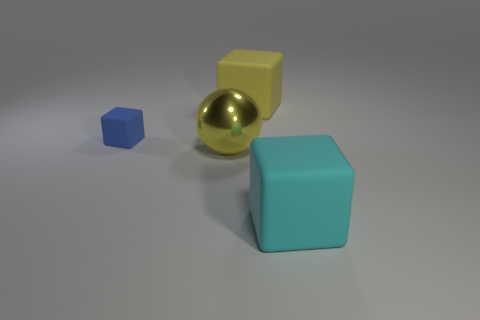Is there any other thing that is the same shape as the yellow metallic thing?
Your answer should be compact. No. What size is the other yellow rubber thing that is the same shape as the small rubber thing?
Your answer should be very brief. Large. Is there anything else that has the same size as the blue matte cube?
Offer a terse response. No. What number of things are either matte objects to the right of the big sphere or matte cubes that are in front of the large yellow cube?
Ensure brevity in your answer.  3. Do the yellow metallic thing and the yellow matte block have the same size?
Make the answer very short. Yes. Is the number of yellow metal balls greater than the number of small purple objects?
Keep it short and to the point. Yes. How many other things are the same color as the tiny thing?
Ensure brevity in your answer.  0. What number of things are small objects or small brown balls?
Offer a terse response. 1. There is a large thing that is in front of the big yellow metal sphere; is its shape the same as the yellow rubber thing?
Provide a short and direct response. Yes. What color is the large rubber object that is on the right side of the yellow thing to the right of the yellow shiny sphere?
Your answer should be compact. Cyan. 